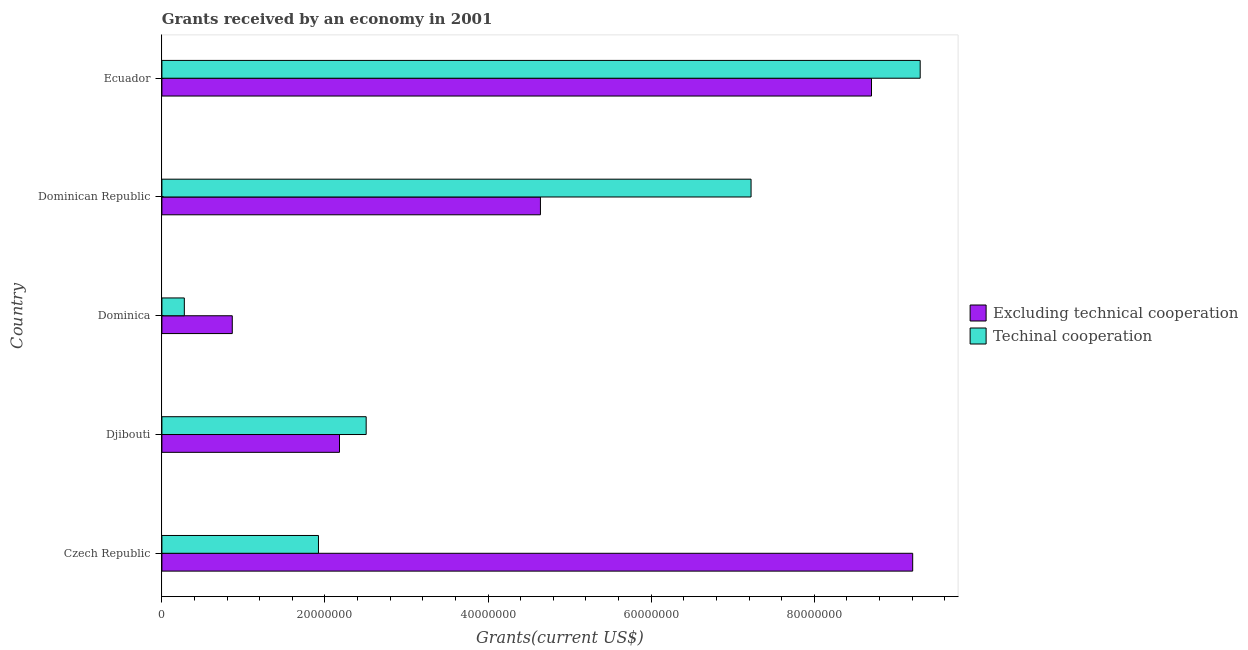How many groups of bars are there?
Provide a succinct answer. 5. How many bars are there on the 1st tick from the bottom?
Offer a very short reply. 2. What is the label of the 2nd group of bars from the top?
Give a very brief answer. Dominican Republic. What is the amount of grants received(excluding technical cooperation) in Dominican Republic?
Offer a very short reply. 4.64e+07. Across all countries, what is the maximum amount of grants received(including technical cooperation)?
Ensure brevity in your answer.  9.30e+07. Across all countries, what is the minimum amount of grants received(excluding technical cooperation)?
Make the answer very short. 8.63e+06. In which country was the amount of grants received(including technical cooperation) maximum?
Your response must be concise. Ecuador. In which country was the amount of grants received(including technical cooperation) minimum?
Your answer should be very brief. Dominica. What is the total amount of grants received(including technical cooperation) in the graph?
Your answer should be very brief. 2.12e+08. What is the difference between the amount of grants received(including technical cooperation) in Dominican Republic and that in Ecuador?
Make the answer very short. -2.07e+07. What is the difference between the amount of grants received(excluding technical cooperation) in Ecuador and the amount of grants received(including technical cooperation) in Czech Republic?
Offer a very short reply. 6.78e+07. What is the average amount of grants received(excluding technical cooperation) per country?
Ensure brevity in your answer.  5.12e+07. What is the difference between the amount of grants received(excluding technical cooperation) and amount of grants received(including technical cooperation) in Djibouti?
Provide a succinct answer. -3.27e+06. In how many countries, is the amount of grants received(including technical cooperation) greater than 16000000 US$?
Give a very brief answer. 4. What is the ratio of the amount of grants received(including technical cooperation) in Czech Republic to that in Ecuador?
Your response must be concise. 0.21. Is the amount of grants received(excluding technical cooperation) in Czech Republic less than that in Dominican Republic?
Provide a short and direct response. No. Is the difference between the amount of grants received(including technical cooperation) in Czech Republic and Dominica greater than the difference between the amount of grants received(excluding technical cooperation) in Czech Republic and Dominica?
Provide a short and direct response. No. What is the difference between the highest and the second highest amount of grants received(including technical cooperation)?
Your answer should be very brief. 2.07e+07. What is the difference between the highest and the lowest amount of grants received(excluding technical cooperation)?
Your answer should be very brief. 8.34e+07. In how many countries, is the amount of grants received(including technical cooperation) greater than the average amount of grants received(including technical cooperation) taken over all countries?
Ensure brevity in your answer.  2. What does the 2nd bar from the top in Djibouti represents?
Make the answer very short. Excluding technical cooperation. What does the 1st bar from the bottom in Djibouti represents?
Provide a succinct answer. Excluding technical cooperation. How many bars are there?
Ensure brevity in your answer.  10. How many countries are there in the graph?
Offer a terse response. 5. What is the difference between two consecutive major ticks on the X-axis?
Ensure brevity in your answer.  2.00e+07. Where does the legend appear in the graph?
Your answer should be very brief. Center right. How many legend labels are there?
Your answer should be very brief. 2. What is the title of the graph?
Make the answer very short. Grants received by an economy in 2001. What is the label or title of the X-axis?
Give a very brief answer. Grants(current US$). What is the label or title of the Y-axis?
Ensure brevity in your answer.  Country. What is the Grants(current US$) of Excluding technical cooperation in Czech Republic?
Give a very brief answer. 9.21e+07. What is the Grants(current US$) in Techinal cooperation in Czech Republic?
Ensure brevity in your answer.  1.92e+07. What is the Grants(current US$) in Excluding technical cooperation in Djibouti?
Ensure brevity in your answer.  2.18e+07. What is the Grants(current US$) of Techinal cooperation in Djibouti?
Keep it short and to the point. 2.50e+07. What is the Grants(current US$) of Excluding technical cooperation in Dominica?
Your answer should be very brief. 8.63e+06. What is the Grants(current US$) in Techinal cooperation in Dominica?
Make the answer very short. 2.75e+06. What is the Grants(current US$) of Excluding technical cooperation in Dominican Republic?
Make the answer very short. 4.64e+07. What is the Grants(current US$) in Techinal cooperation in Dominican Republic?
Keep it short and to the point. 7.22e+07. What is the Grants(current US$) in Excluding technical cooperation in Ecuador?
Make the answer very short. 8.70e+07. What is the Grants(current US$) of Techinal cooperation in Ecuador?
Offer a terse response. 9.30e+07. Across all countries, what is the maximum Grants(current US$) in Excluding technical cooperation?
Give a very brief answer. 9.21e+07. Across all countries, what is the maximum Grants(current US$) in Techinal cooperation?
Your answer should be compact. 9.30e+07. Across all countries, what is the minimum Grants(current US$) of Excluding technical cooperation?
Your answer should be very brief. 8.63e+06. Across all countries, what is the minimum Grants(current US$) in Techinal cooperation?
Provide a short and direct response. 2.75e+06. What is the total Grants(current US$) in Excluding technical cooperation in the graph?
Keep it short and to the point. 2.56e+08. What is the total Grants(current US$) in Techinal cooperation in the graph?
Offer a terse response. 2.12e+08. What is the difference between the Grants(current US$) in Excluding technical cooperation in Czech Republic and that in Djibouti?
Provide a short and direct response. 7.03e+07. What is the difference between the Grants(current US$) of Techinal cooperation in Czech Republic and that in Djibouti?
Offer a very short reply. -5.85e+06. What is the difference between the Grants(current US$) in Excluding technical cooperation in Czech Republic and that in Dominica?
Offer a very short reply. 8.34e+07. What is the difference between the Grants(current US$) of Techinal cooperation in Czech Republic and that in Dominica?
Give a very brief answer. 1.64e+07. What is the difference between the Grants(current US$) in Excluding technical cooperation in Czech Republic and that in Dominican Republic?
Make the answer very short. 4.56e+07. What is the difference between the Grants(current US$) in Techinal cooperation in Czech Republic and that in Dominican Republic?
Your answer should be very brief. -5.30e+07. What is the difference between the Grants(current US$) of Excluding technical cooperation in Czech Republic and that in Ecuador?
Make the answer very short. 5.05e+06. What is the difference between the Grants(current US$) of Techinal cooperation in Czech Republic and that in Ecuador?
Your response must be concise. -7.38e+07. What is the difference between the Grants(current US$) in Excluding technical cooperation in Djibouti and that in Dominica?
Your answer should be very brief. 1.32e+07. What is the difference between the Grants(current US$) in Techinal cooperation in Djibouti and that in Dominica?
Your answer should be very brief. 2.23e+07. What is the difference between the Grants(current US$) in Excluding technical cooperation in Djibouti and that in Dominican Republic?
Your response must be concise. -2.46e+07. What is the difference between the Grants(current US$) in Techinal cooperation in Djibouti and that in Dominican Republic?
Keep it short and to the point. -4.72e+07. What is the difference between the Grants(current US$) of Excluding technical cooperation in Djibouti and that in Ecuador?
Keep it short and to the point. -6.52e+07. What is the difference between the Grants(current US$) of Techinal cooperation in Djibouti and that in Ecuador?
Your answer should be compact. -6.79e+07. What is the difference between the Grants(current US$) of Excluding technical cooperation in Dominica and that in Dominican Republic?
Make the answer very short. -3.78e+07. What is the difference between the Grants(current US$) in Techinal cooperation in Dominica and that in Dominican Republic?
Give a very brief answer. -6.95e+07. What is the difference between the Grants(current US$) in Excluding technical cooperation in Dominica and that in Ecuador?
Make the answer very short. -7.84e+07. What is the difference between the Grants(current US$) in Techinal cooperation in Dominica and that in Ecuador?
Your response must be concise. -9.02e+07. What is the difference between the Grants(current US$) of Excluding technical cooperation in Dominican Republic and that in Ecuador?
Keep it short and to the point. -4.06e+07. What is the difference between the Grants(current US$) of Techinal cooperation in Dominican Republic and that in Ecuador?
Provide a short and direct response. -2.07e+07. What is the difference between the Grants(current US$) of Excluding technical cooperation in Czech Republic and the Grants(current US$) of Techinal cooperation in Djibouti?
Your answer should be compact. 6.70e+07. What is the difference between the Grants(current US$) of Excluding technical cooperation in Czech Republic and the Grants(current US$) of Techinal cooperation in Dominica?
Offer a terse response. 8.93e+07. What is the difference between the Grants(current US$) of Excluding technical cooperation in Czech Republic and the Grants(current US$) of Techinal cooperation in Dominican Republic?
Offer a very short reply. 1.98e+07. What is the difference between the Grants(current US$) of Excluding technical cooperation in Czech Republic and the Grants(current US$) of Techinal cooperation in Ecuador?
Offer a very short reply. -9.20e+05. What is the difference between the Grants(current US$) in Excluding technical cooperation in Djibouti and the Grants(current US$) in Techinal cooperation in Dominica?
Your answer should be very brief. 1.90e+07. What is the difference between the Grants(current US$) of Excluding technical cooperation in Djibouti and the Grants(current US$) of Techinal cooperation in Dominican Republic?
Provide a short and direct response. -5.05e+07. What is the difference between the Grants(current US$) in Excluding technical cooperation in Djibouti and the Grants(current US$) in Techinal cooperation in Ecuador?
Ensure brevity in your answer.  -7.12e+07. What is the difference between the Grants(current US$) in Excluding technical cooperation in Dominica and the Grants(current US$) in Techinal cooperation in Dominican Republic?
Ensure brevity in your answer.  -6.36e+07. What is the difference between the Grants(current US$) in Excluding technical cooperation in Dominica and the Grants(current US$) in Techinal cooperation in Ecuador?
Your answer should be very brief. -8.44e+07. What is the difference between the Grants(current US$) of Excluding technical cooperation in Dominican Republic and the Grants(current US$) of Techinal cooperation in Ecuador?
Your answer should be compact. -4.66e+07. What is the average Grants(current US$) of Excluding technical cooperation per country?
Offer a terse response. 5.12e+07. What is the average Grants(current US$) of Techinal cooperation per country?
Provide a succinct answer. 4.24e+07. What is the difference between the Grants(current US$) of Excluding technical cooperation and Grants(current US$) of Techinal cooperation in Czech Republic?
Provide a short and direct response. 7.29e+07. What is the difference between the Grants(current US$) in Excluding technical cooperation and Grants(current US$) in Techinal cooperation in Djibouti?
Your answer should be very brief. -3.27e+06. What is the difference between the Grants(current US$) in Excluding technical cooperation and Grants(current US$) in Techinal cooperation in Dominica?
Offer a terse response. 5.88e+06. What is the difference between the Grants(current US$) in Excluding technical cooperation and Grants(current US$) in Techinal cooperation in Dominican Republic?
Ensure brevity in your answer.  -2.58e+07. What is the difference between the Grants(current US$) of Excluding technical cooperation and Grants(current US$) of Techinal cooperation in Ecuador?
Ensure brevity in your answer.  -5.97e+06. What is the ratio of the Grants(current US$) of Excluding technical cooperation in Czech Republic to that in Djibouti?
Your answer should be compact. 4.23. What is the ratio of the Grants(current US$) in Techinal cooperation in Czech Republic to that in Djibouti?
Provide a succinct answer. 0.77. What is the ratio of the Grants(current US$) of Excluding technical cooperation in Czech Republic to that in Dominica?
Give a very brief answer. 10.67. What is the ratio of the Grants(current US$) in Techinal cooperation in Czech Republic to that in Dominica?
Provide a succinct answer. 6.98. What is the ratio of the Grants(current US$) of Excluding technical cooperation in Czech Republic to that in Dominican Republic?
Provide a short and direct response. 1.98. What is the ratio of the Grants(current US$) in Techinal cooperation in Czech Republic to that in Dominican Republic?
Give a very brief answer. 0.27. What is the ratio of the Grants(current US$) in Excluding technical cooperation in Czech Republic to that in Ecuador?
Offer a very short reply. 1.06. What is the ratio of the Grants(current US$) in Techinal cooperation in Czech Republic to that in Ecuador?
Provide a succinct answer. 0.21. What is the ratio of the Grants(current US$) of Excluding technical cooperation in Djibouti to that in Dominica?
Offer a very short reply. 2.52. What is the ratio of the Grants(current US$) of Techinal cooperation in Djibouti to that in Dominica?
Provide a short and direct response. 9.11. What is the ratio of the Grants(current US$) in Excluding technical cooperation in Djibouti to that in Dominican Republic?
Your response must be concise. 0.47. What is the ratio of the Grants(current US$) in Techinal cooperation in Djibouti to that in Dominican Republic?
Provide a succinct answer. 0.35. What is the ratio of the Grants(current US$) in Excluding technical cooperation in Djibouti to that in Ecuador?
Your response must be concise. 0.25. What is the ratio of the Grants(current US$) in Techinal cooperation in Djibouti to that in Ecuador?
Your answer should be very brief. 0.27. What is the ratio of the Grants(current US$) of Excluding technical cooperation in Dominica to that in Dominican Republic?
Your response must be concise. 0.19. What is the ratio of the Grants(current US$) in Techinal cooperation in Dominica to that in Dominican Republic?
Provide a succinct answer. 0.04. What is the ratio of the Grants(current US$) in Excluding technical cooperation in Dominica to that in Ecuador?
Your answer should be compact. 0.1. What is the ratio of the Grants(current US$) in Techinal cooperation in Dominica to that in Ecuador?
Offer a very short reply. 0.03. What is the ratio of the Grants(current US$) in Excluding technical cooperation in Dominican Republic to that in Ecuador?
Provide a short and direct response. 0.53. What is the ratio of the Grants(current US$) in Techinal cooperation in Dominican Republic to that in Ecuador?
Make the answer very short. 0.78. What is the difference between the highest and the second highest Grants(current US$) of Excluding technical cooperation?
Make the answer very short. 5.05e+06. What is the difference between the highest and the second highest Grants(current US$) of Techinal cooperation?
Make the answer very short. 2.07e+07. What is the difference between the highest and the lowest Grants(current US$) in Excluding technical cooperation?
Keep it short and to the point. 8.34e+07. What is the difference between the highest and the lowest Grants(current US$) in Techinal cooperation?
Offer a terse response. 9.02e+07. 